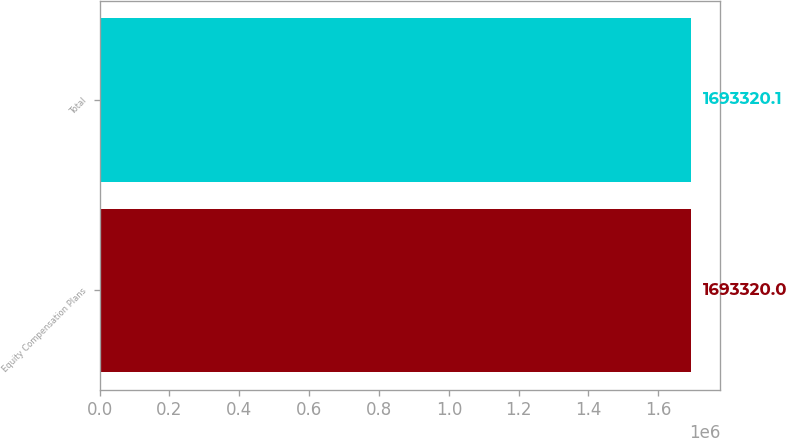Convert chart. <chart><loc_0><loc_0><loc_500><loc_500><bar_chart><fcel>Equity Compensation Plans<fcel>Total<nl><fcel>1.69332e+06<fcel>1.69332e+06<nl></chart> 